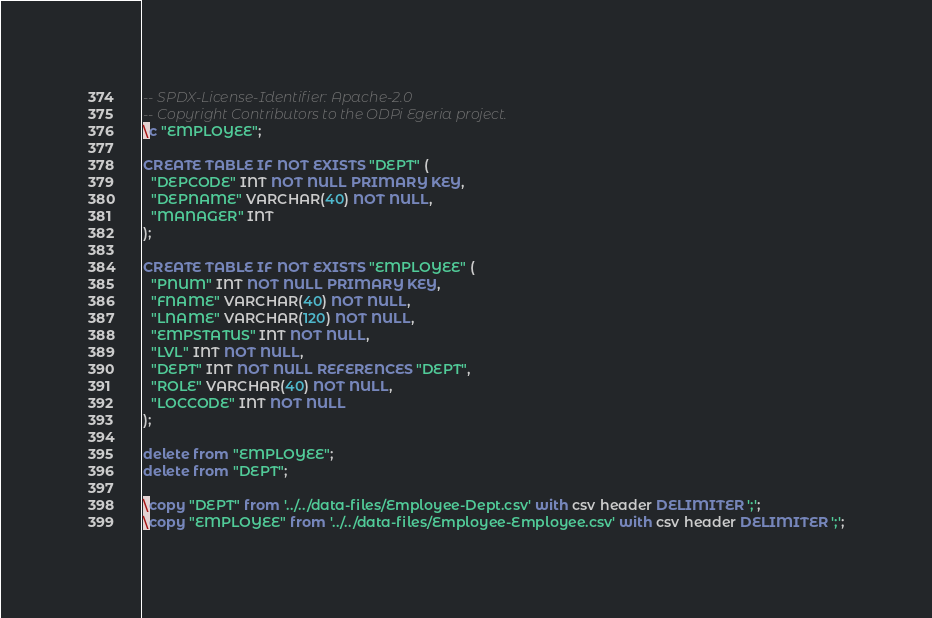<code> <loc_0><loc_0><loc_500><loc_500><_SQL_>-- SPDX-License-Identifier: Apache-2.0
-- Copyright Contributors to the ODPi Egeria project.
\c "EMPLOYEE";

CREATE TABLE IF NOT EXISTS "DEPT" (
  "DEPCODE" INT NOT NULL PRIMARY KEY,
  "DEPNAME" VARCHAR(40) NOT NULL,
  "MANAGER" INT
);

CREATE TABLE IF NOT EXISTS "EMPLOYEE" (
  "PNUM" INT NOT NULL PRIMARY KEY,
  "FNAME" VARCHAR(40) NOT NULL,
  "LNAME" VARCHAR(120) NOT NULL,
  "EMPSTATUS" INT NOT NULL,
  "LVL" INT NOT NULL,
  "DEPT" INT NOT NULL REFERENCES "DEPT",
  "ROLE" VARCHAR(40) NOT NULL,
  "LOCCODE" INT NOT NULL
);

delete from "EMPLOYEE";
delete from "DEPT";

\copy "DEPT" from '../../data-files/Employee-Dept.csv' with csv header DELIMITER ';';
\copy "EMPLOYEE" from '../../data-files/Employee-Employee.csv' with csv header DELIMITER ';';
</code> 